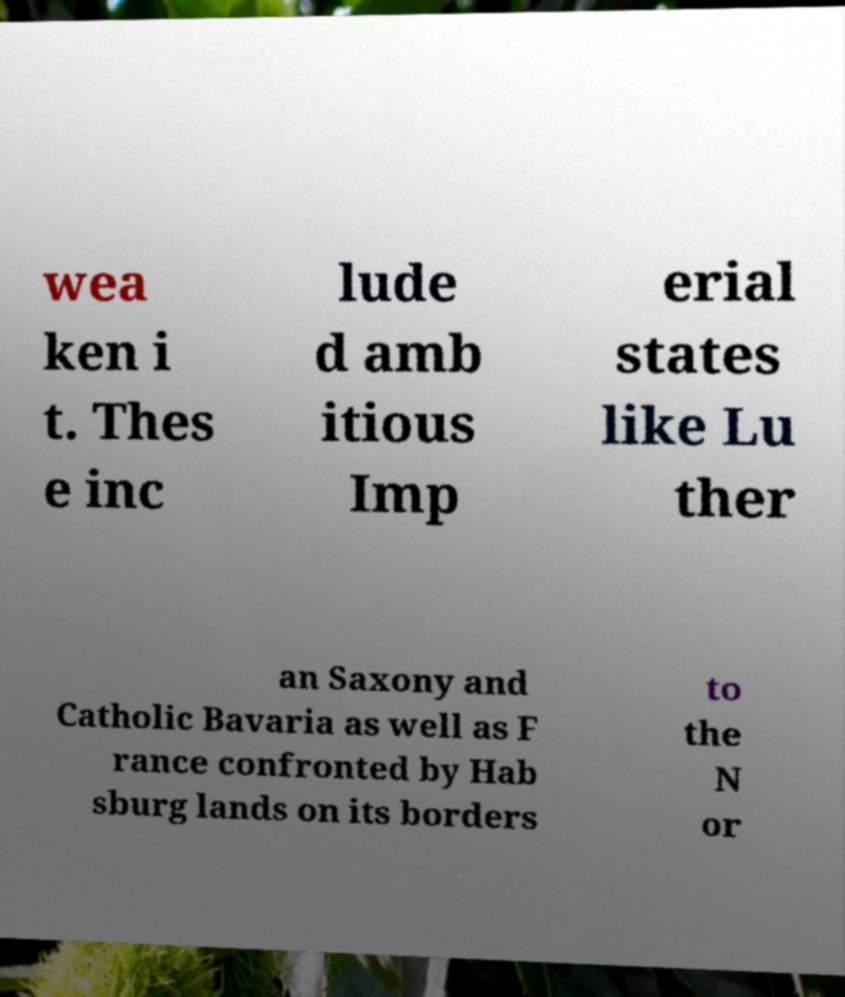Please read and relay the text visible in this image. What does it say? wea ken i t. Thes e inc lude d amb itious Imp erial states like Lu ther an Saxony and Catholic Bavaria as well as F rance confronted by Hab sburg lands on its borders to the N or 